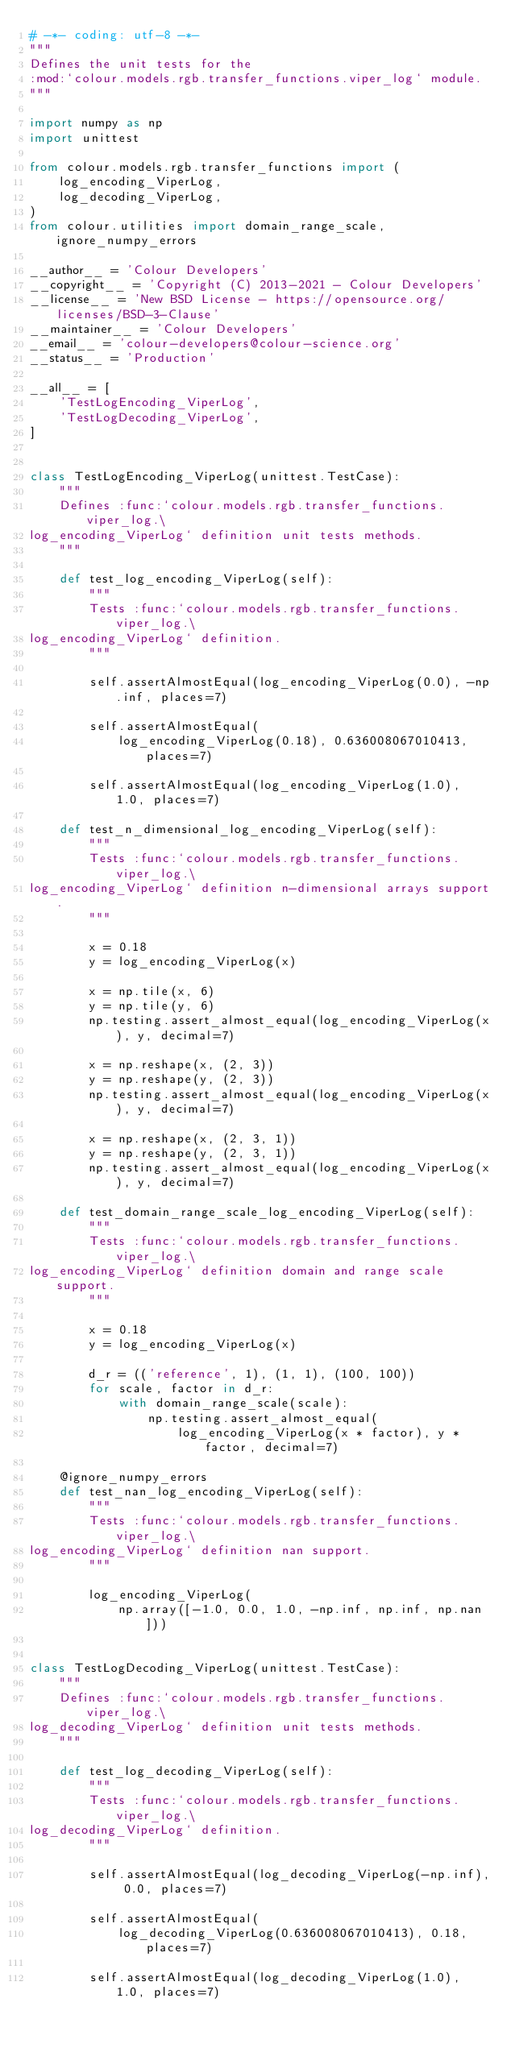Convert code to text. <code><loc_0><loc_0><loc_500><loc_500><_Python_># -*- coding: utf-8 -*-
"""
Defines the unit tests for the
:mod:`colour.models.rgb.transfer_functions.viper_log` module.
"""

import numpy as np
import unittest

from colour.models.rgb.transfer_functions import (
    log_encoding_ViperLog,
    log_decoding_ViperLog,
)
from colour.utilities import domain_range_scale, ignore_numpy_errors

__author__ = 'Colour Developers'
__copyright__ = 'Copyright (C) 2013-2021 - Colour Developers'
__license__ = 'New BSD License - https://opensource.org/licenses/BSD-3-Clause'
__maintainer__ = 'Colour Developers'
__email__ = 'colour-developers@colour-science.org'
__status__ = 'Production'

__all__ = [
    'TestLogEncoding_ViperLog',
    'TestLogDecoding_ViperLog',
]


class TestLogEncoding_ViperLog(unittest.TestCase):
    """
    Defines :func:`colour.models.rgb.transfer_functions.viper_log.\
log_encoding_ViperLog` definition unit tests methods.
    """

    def test_log_encoding_ViperLog(self):
        """
        Tests :func:`colour.models.rgb.transfer_functions.viper_log.\
log_encoding_ViperLog` definition.
        """

        self.assertAlmostEqual(log_encoding_ViperLog(0.0), -np.inf, places=7)

        self.assertAlmostEqual(
            log_encoding_ViperLog(0.18), 0.636008067010413, places=7)

        self.assertAlmostEqual(log_encoding_ViperLog(1.0), 1.0, places=7)

    def test_n_dimensional_log_encoding_ViperLog(self):
        """
        Tests :func:`colour.models.rgb.transfer_functions.viper_log.\
log_encoding_ViperLog` definition n-dimensional arrays support.
        """

        x = 0.18
        y = log_encoding_ViperLog(x)

        x = np.tile(x, 6)
        y = np.tile(y, 6)
        np.testing.assert_almost_equal(log_encoding_ViperLog(x), y, decimal=7)

        x = np.reshape(x, (2, 3))
        y = np.reshape(y, (2, 3))
        np.testing.assert_almost_equal(log_encoding_ViperLog(x), y, decimal=7)

        x = np.reshape(x, (2, 3, 1))
        y = np.reshape(y, (2, 3, 1))
        np.testing.assert_almost_equal(log_encoding_ViperLog(x), y, decimal=7)

    def test_domain_range_scale_log_encoding_ViperLog(self):
        """
        Tests :func:`colour.models.rgb.transfer_functions.viper_log.\
log_encoding_ViperLog` definition domain and range scale support.
        """

        x = 0.18
        y = log_encoding_ViperLog(x)

        d_r = (('reference', 1), (1, 1), (100, 100))
        for scale, factor in d_r:
            with domain_range_scale(scale):
                np.testing.assert_almost_equal(
                    log_encoding_ViperLog(x * factor), y * factor, decimal=7)

    @ignore_numpy_errors
    def test_nan_log_encoding_ViperLog(self):
        """
        Tests :func:`colour.models.rgb.transfer_functions.viper_log.\
log_encoding_ViperLog` definition nan support.
        """

        log_encoding_ViperLog(
            np.array([-1.0, 0.0, 1.0, -np.inf, np.inf, np.nan]))


class TestLogDecoding_ViperLog(unittest.TestCase):
    """
    Defines :func:`colour.models.rgb.transfer_functions.viper_log.\
log_decoding_ViperLog` definition unit tests methods.
    """

    def test_log_decoding_ViperLog(self):
        """
        Tests :func:`colour.models.rgb.transfer_functions.viper_log.\
log_decoding_ViperLog` definition.
        """

        self.assertAlmostEqual(log_decoding_ViperLog(-np.inf), 0.0, places=7)

        self.assertAlmostEqual(
            log_decoding_ViperLog(0.636008067010413), 0.18, places=7)

        self.assertAlmostEqual(log_decoding_ViperLog(1.0), 1.0, places=7)
</code> 